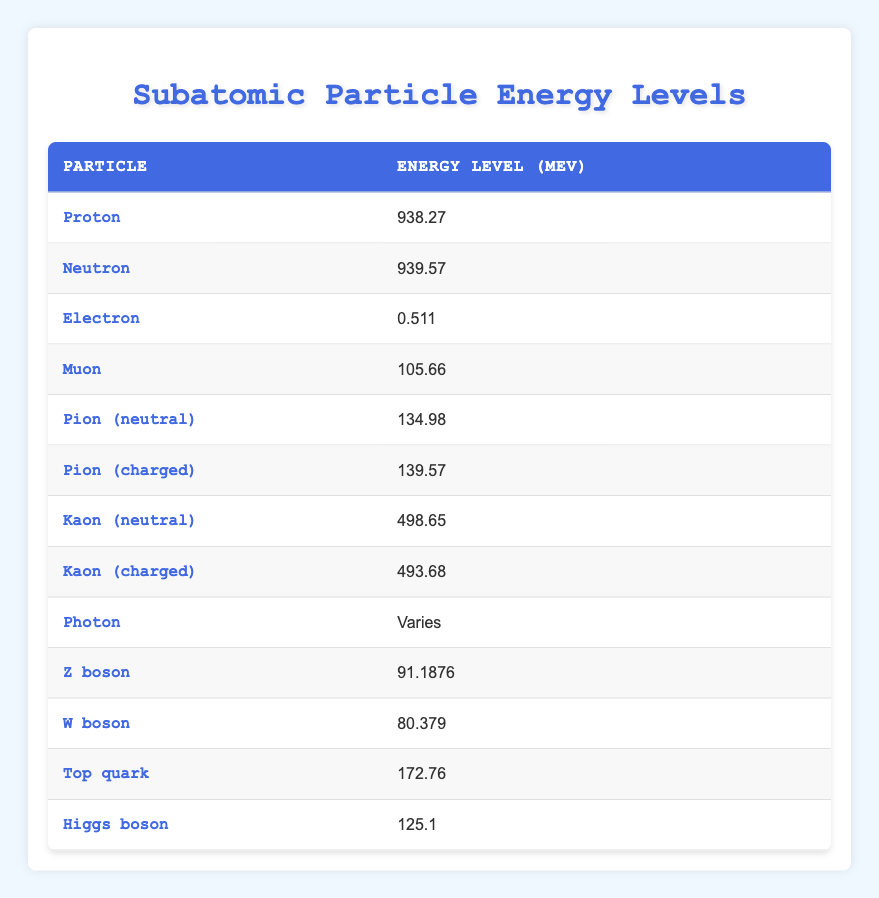What is the energy level of the Proton? The table lists the energy level of the Proton as 938.27 MeV. This information can be found in the first row of the table under the respective columns.
Answer: 938.27 MeV Which particle has an energy level closest to 100 MeV? By examining the energy levels in the table, the Muon has an energy level of 105.66 MeV, which is the closest to 100 MeV when compared with all other particles listed.
Answer: Muon: 105.66 MeV Is the energy level of the Neutron greater than that of the Kaon (charged)? The Neutron has an energy level of 939.57 MeV, while the Kaon (charged) has an energy level of 493.68 MeV. Since 939.57 is greater than 493.68, the statement is true.
Answer: Yes What is the energy level difference between the Proton and the Electron? The energy level of the Proton is 938.27 MeV, and the Electron is 0.511 MeV. To find the difference, we subtract the Electron's energy from the Proton's: 938.27 - 0.511 = 937.759.
Answer: 937.759 MeV How many particles have an energy level greater than 500 MeV? Reviewing the table, the following particles have energy levels greater than 500 MeV: Proton (938.27), Neutron (939.57), Kaon (neutral) (498.65), and Kaon (charged) (493.68). However, only the first two exceed 500 MeV. Therefore, there are 3 particles.
Answer: 3 What is the average energy level of charged particles (Pion (charged), Kaon (charged), W boson)? The energy levels of the charged particles are: Pion (charged) 139.57 MeV, Kaon (charged) 493.68 MeV, and W boson 80.379 MeV. The average is calculated by summing these values (139.57 + 493.68 + 80.379) = 713.629 and then dividing by the number of particles (3): 713.629 / 3 = 237.87633.
Answer: 237.88 MeV Is the energy level of the Higgs boson greater than that of the Top quark? The Higgs boson has an energy level of 125.1 MeV, while the Top quark has an energy level of 172.76 MeV. Comparing these values shows that Higgs boson is indeed less than Top quark's energy level. Therefore, the statement is false.
Answer: No What is the total energy of all the listed particles? The total energy is calculated by summing all the energy levels of the particles. The total for all listed is: 938.27 + 939.57 + 0.511 + 105.66 + 134.98 + 139.57 + 498.65 + 493.68 + 91.1876 + 80.379 + 172.76 + 125.1 = 2999.0546 MeV.
Answer: 2999.05 MeV 